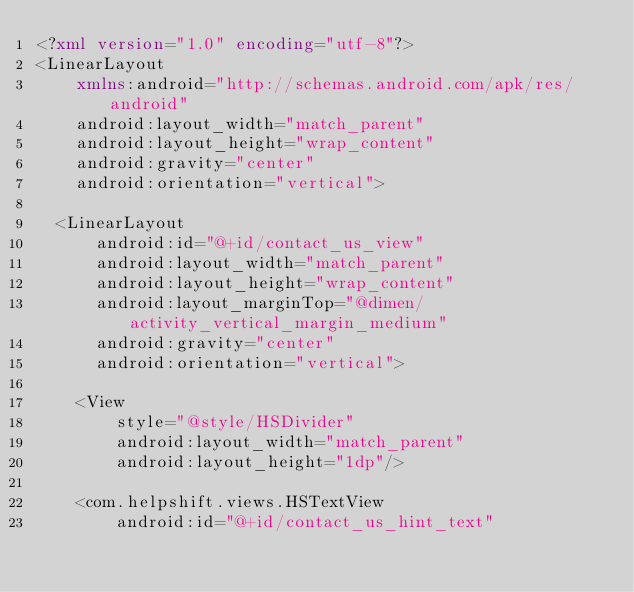Convert code to text. <code><loc_0><loc_0><loc_500><loc_500><_XML_><?xml version="1.0" encoding="utf-8"?>
<LinearLayout
    xmlns:android="http://schemas.android.com/apk/res/android"
    android:layout_width="match_parent"
    android:layout_height="wrap_content"
    android:gravity="center"
    android:orientation="vertical">

  <LinearLayout
      android:id="@+id/contact_us_view"
      android:layout_width="match_parent"
      android:layout_height="wrap_content"
      android:layout_marginTop="@dimen/activity_vertical_margin_medium"
      android:gravity="center"
      android:orientation="vertical">

    <View
        style="@style/HSDivider"
        android:layout_width="match_parent"
        android:layout_height="1dp"/>

    <com.helpshift.views.HSTextView
        android:id="@+id/contact_us_hint_text"</code> 